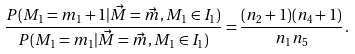Convert formula to latex. <formula><loc_0><loc_0><loc_500><loc_500>\frac { P ( M _ { 1 } = m _ { 1 } + 1 | \vec { M } = \vec { m } , M _ { 1 } \in I _ { 1 } ) } { P ( M _ { 1 } = m _ { 1 } | \vec { M } = \vec { m } , M _ { 1 } \in I _ { 1 } ) } = \frac { ( n _ { 2 } + 1 ) ( n _ { 4 } + 1 ) } { n _ { 1 } n _ { 5 } } \, .</formula> 